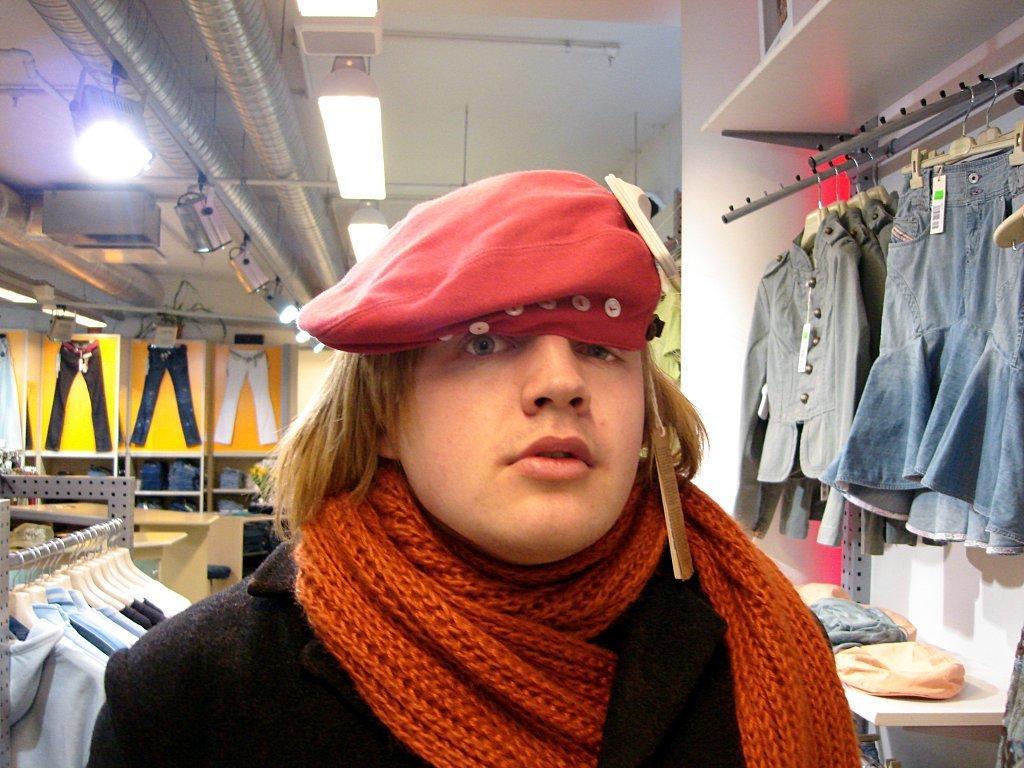In one or two sentences, can you explain what this image depicts? In this picture we can see a person wearing a cap and a scarf. We can see objects and clothes. We can see clothes hanging with the help of hangers. In the background we can see pants on the wall. At the top we can see the ceiling, lights and objects. On the right side of the picture we can see objects on the shelf. 